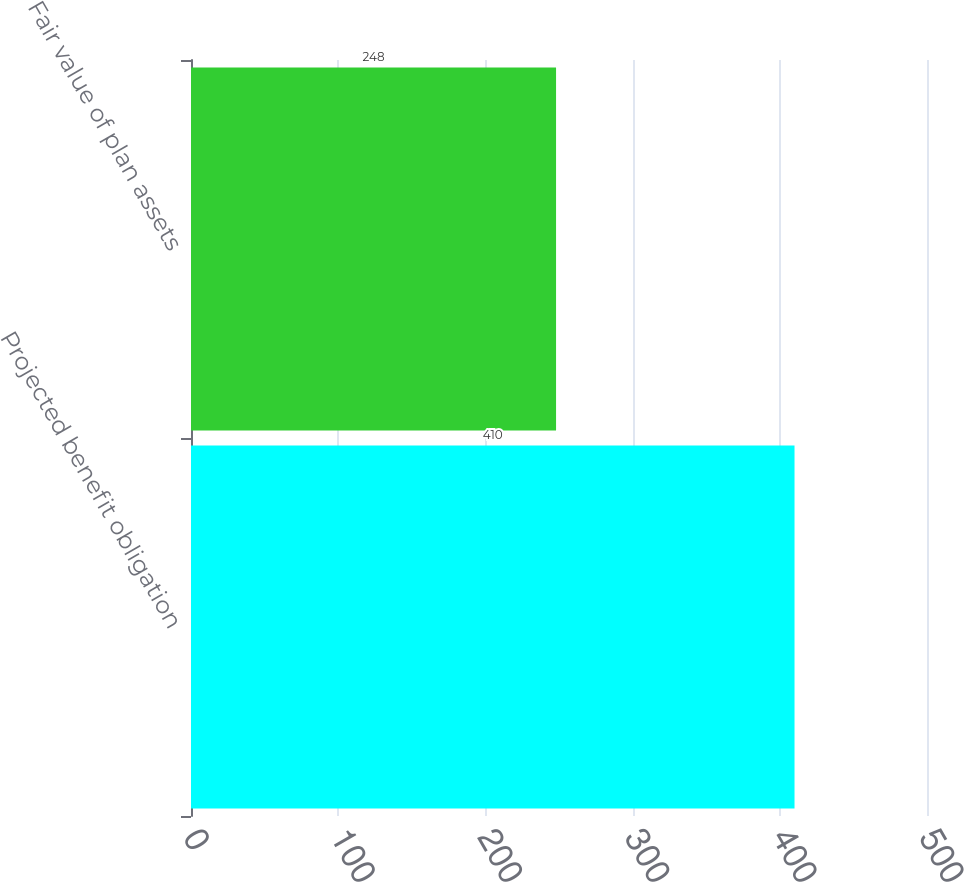Convert chart to OTSL. <chart><loc_0><loc_0><loc_500><loc_500><bar_chart><fcel>Projected benefit obligation<fcel>Fair value of plan assets<nl><fcel>410<fcel>248<nl></chart> 